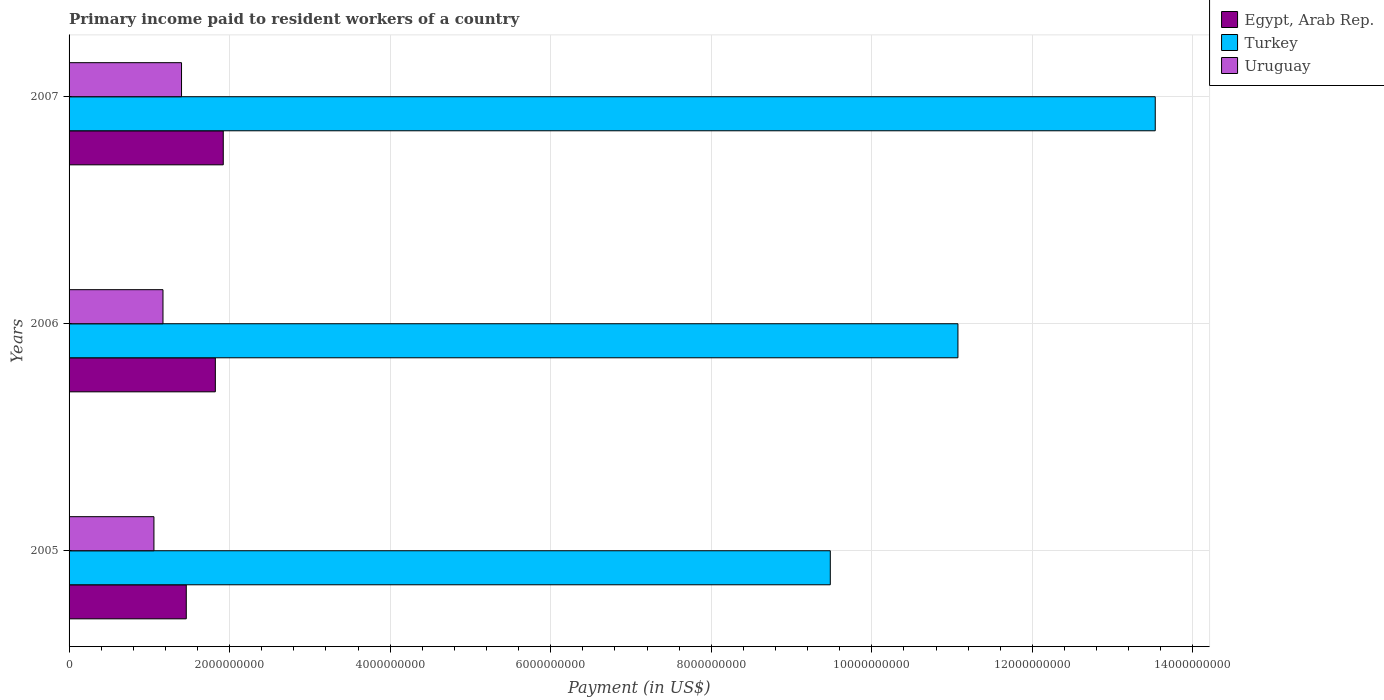How many different coloured bars are there?
Ensure brevity in your answer.  3. How many groups of bars are there?
Keep it short and to the point. 3. Are the number of bars per tick equal to the number of legend labels?
Your response must be concise. Yes. Are the number of bars on each tick of the Y-axis equal?
Ensure brevity in your answer.  Yes. How many bars are there on the 3rd tick from the top?
Your answer should be very brief. 3. In how many cases, is the number of bars for a given year not equal to the number of legend labels?
Keep it short and to the point. 0. What is the amount paid to workers in Uruguay in 2007?
Offer a terse response. 1.40e+09. Across all years, what is the maximum amount paid to workers in Egypt, Arab Rep.?
Give a very brief answer. 1.92e+09. Across all years, what is the minimum amount paid to workers in Turkey?
Your response must be concise. 9.48e+09. In which year was the amount paid to workers in Egypt, Arab Rep. minimum?
Your answer should be very brief. 2005. What is the total amount paid to workers in Uruguay in the graph?
Your answer should be compact. 3.63e+09. What is the difference between the amount paid to workers in Turkey in 2005 and that in 2006?
Your answer should be compact. -1.59e+09. What is the difference between the amount paid to workers in Egypt, Arab Rep. in 2006 and the amount paid to workers in Uruguay in 2005?
Offer a very short reply. 7.65e+08. What is the average amount paid to workers in Egypt, Arab Rep. per year?
Offer a terse response. 1.73e+09. In the year 2006, what is the difference between the amount paid to workers in Egypt, Arab Rep. and amount paid to workers in Turkey?
Give a very brief answer. -9.25e+09. What is the ratio of the amount paid to workers in Uruguay in 2006 to that in 2007?
Your response must be concise. 0.84. Is the difference between the amount paid to workers in Egypt, Arab Rep. in 2006 and 2007 greater than the difference between the amount paid to workers in Turkey in 2006 and 2007?
Provide a short and direct response. Yes. What is the difference between the highest and the second highest amount paid to workers in Uruguay?
Provide a short and direct response. 2.31e+08. What is the difference between the highest and the lowest amount paid to workers in Egypt, Arab Rep.?
Give a very brief answer. 4.61e+08. In how many years, is the amount paid to workers in Uruguay greater than the average amount paid to workers in Uruguay taken over all years?
Offer a very short reply. 1. Is the sum of the amount paid to workers in Uruguay in 2005 and 2006 greater than the maximum amount paid to workers in Egypt, Arab Rep. across all years?
Make the answer very short. Yes. What does the 2nd bar from the top in 2007 represents?
Keep it short and to the point. Turkey. What does the 1st bar from the bottom in 2007 represents?
Ensure brevity in your answer.  Egypt, Arab Rep. Is it the case that in every year, the sum of the amount paid to workers in Uruguay and amount paid to workers in Egypt, Arab Rep. is greater than the amount paid to workers in Turkey?
Keep it short and to the point. No. How many bars are there?
Your response must be concise. 9. Are all the bars in the graph horizontal?
Your answer should be compact. Yes. How many years are there in the graph?
Provide a short and direct response. 3. What is the difference between two consecutive major ticks on the X-axis?
Provide a succinct answer. 2.00e+09. Does the graph contain any zero values?
Your answer should be very brief. No. Where does the legend appear in the graph?
Offer a terse response. Top right. How are the legend labels stacked?
Provide a succinct answer. Vertical. What is the title of the graph?
Provide a short and direct response. Primary income paid to resident workers of a country. Does "Papua New Guinea" appear as one of the legend labels in the graph?
Offer a very short reply. No. What is the label or title of the X-axis?
Provide a succinct answer. Payment (in US$). What is the label or title of the Y-axis?
Ensure brevity in your answer.  Years. What is the Payment (in US$) of Egypt, Arab Rep. in 2005?
Provide a succinct answer. 1.46e+09. What is the Payment (in US$) of Turkey in 2005?
Ensure brevity in your answer.  9.48e+09. What is the Payment (in US$) of Uruguay in 2005?
Offer a terse response. 1.06e+09. What is the Payment (in US$) in Egypt, Arab Rep. in 2006?
Offer a very short reply. 1.82e+09. What is the Payment (in US$) of Turkey in 2006?
Ensure brevity in your answer.  1.11e+1. What is the Payment (in US$) of Uruguay in 2006?
Keep it short and to the point. 1.17e+09. What is the Payment (in US$) of Egypt, Arab Rep. in 2007?
Make the answer very short. 1.92e+09. What is the Payment (in US$) of Turkey in 2007?
Offer a terse response. 1.35e+1. What is the Payment (in US$) in Uruguay in 2007?
Offer a terse response. 1.40e+09. Across all years, what is the maximum Payment (in US$) in Egypt, Arab Rep.?
Ensure brevity in your answer.  1.92e+09. Across all years, what is the maximum Payment (in US$) of Turkey?
Your answer should be compact. 1.35e+1. Across all years, what is the maximum Payment (in US$) of Uruguay?
Provide a short and direct response. 1.40e+09. Across all years, what is the minimum Payment (in US$) in Egypt, Arab Rep.?
Provide a short and direct response. 1.46e+09. Across all years, what is the minimum Payment (in US$) in Turkey?
Keep it short and to the point. 9.48e+09. Across all years, what is the minimum Payment (in US$) of Uruguay?
Keep it short and to the point. 1.06e+09. What is the total Payment (in US$) of Egypt, Arab Rep. in the graph?
Your response must be concise. 5.20e+09. What is the total Payment (in US$) of Turkey in the graph?
Provide a short and direct response. 3.41e+1. What is the total Payment (in US$) of Uruguay in the graph?
Keep it short and to the point. 3.63e+09. What is the difference between the Payment (in US$) in Egypt, Arab Rep. in 2005 and that in 2006?
Provide a short and direct response. -3.62e+08. What is the difference between the Payment (in US$) of Turkey in 2005 and that in 2006?
Give a very brief answer. -1.59e+09. What is the difference between the Payment (in US$) of Uruguay in 2005 and that in 2006?
Your answer should be compact. -1.13e+08. What is the difference between the Payment (in US$) of Egypt, Arab Rep. in 2005 and that in 2007?
Make the answer very short. -4.61e+08. What is the difference between the Payment (in US$) of Turkey in 2005 and that in 2007?
Your response must be concise. -4.05e+09. What is the difference between the Payment (in US$) in Uruguay in 2005 and that in 2007?
Ensure brevity in your answer.  -3.44e+08. What is the difference between the Payment (in US$) in Egypt, Arab Rep. in 2006 and that in 2007?
Provide a succinct answer. -9.87e+07. What is the difference between the Payment (in US$) in Turkey in 2006 and that in 2007?
Your answer should be very brief. -2.46e+09. What is the difference between the Payment (in US$) of Uruguay in 2006 and that in 2007?
Provide a succinct answer. -2.31e+08. What is the difference between the Payment (in US$) in Egypt, Arab Rep. in 2005 and the Payment (in US$) in Turkey in 2006?
Your answer should be very brief. -9.61e+09. What is the difference between the Payment (in US$) of Egypt, Arab Rep. in 2005 and the Payment (in US$) of Uruguay in 2006?
Provide a succinct answer. 2.90e+08. What is the difference between the Payment (in US$) of Turkey in 2005 and the Payment (in US$) of Uruguay in 2006?
Offer a terse response. 8.31e+09. What is the difference between the Payment (in US$) of Egypt, Arab Rep. in 2005 and the Payment (in US$) of Turkey in 2007?
Provide a short and direct response. -1.21e+1. What is the difference between the Payment (in US$) of Egypt, Arab Rep. in 2005 and the Payment (in US$) of Uruguay in 2007?
Offer a very short reply. 5.93e+07. What is the difference between the Payment (in US$) in Turkey in 2005 and the Payment (in US$) in Uruguay in 2007?
Ensure brevity in your answer.  8.08e+09. What is the difference between the Payment (in US$) in Egypt, Arab Rep. in 2006 and the Payment (in US$) in Turkey in 2007?
Your answer should be very brief. -1.17e+1. What is the difference between the Payment (in US$) of Egypt, Arab Rep. in 2006 and the Payment (in US$) of Uruguay in 2007?
Your answer should be very brief. 4.21e+08. What is the difference between the Payment (in US$) in Turkey in 2006 and the Payment (in US$) in Uruguay in 2007?
Give a very brief answer. 9.67e+09. What is the average Payment (in US$) of Egypt, Arab Rep. per year?
Provide a succinct answer. 1.73e+09. What is the average Payment (in US$) in Turkey per year?
Offer a terse response. 1.14e+1. What is the average Payment (in US$) of Uruguay per year?
Your answer should be very brief. 1.21e+09. In the year 2005, what is the difference between the Payment (in US$) in Egypt, Arab Rep. and Payment (in US$) in Turkey?
Offer a terse response. -8.02e+09. In the year 2005, what is the difference between the Payment (in US$) in Egypt, Arab Rep. and Payment (in US$) in Uruguay?
Keep it short and to the point. 4.03e+08. In the year 2005, what is the difference between the Payment (in US$) in Turkey and Payment (in US$) in Uruguay?
Ensure brevity in your answer.  8.43e+09. In the year 2006, what is the difference between the Payment (in US$) in Egypt, Arab Rep. and Payment (in US$) in Turkey?
Make the answer very short. -9.25e+09. In the year 2006, what is the difference between the Payment (in US$) of Egypt, Arab Rep. and Payment (in US$) of Uruguay?
Your answer should be compact. 6.52e+08. In the year 2006, what is the difference between the Payment (in US$) of Turkey and Payment (in US$) of Uruguay?
Your answer should be compact. 9.90e+09. In the year 2007, what is the difference between the Payment (in US$) of Egypt, Arab Rep. and Payment (in US$) of Turkey?
Provide a succinct answer. -1.16e+1. In the year 2007, what is the difference between the Payment (in US$) in Egypt, Arab Rep. and Payment (in US$) in Uruguay?
Offer a terse response. 5.20e+08. In the year 2007, what is the difference between the Payment (in US$) in Turkey and Payment (in US$) in Uruguay?
Provide a succinct answer. 1.21e+1. What is the ratio of the Payment (in US$) of Egypt, Arab Rep. in 2005 to that in 2006?
Offer a very short reply. 0.8. What is the ratio of the Payment (in US$) in Turkey in 2005 to that in 2006?
Your response must be concise. 0.86. What is the ratio of the Payment (in US$) of Uruguay in 2005 to that in 2006?
Ensure brevity in your answer.  0.9. What is the ratio of the Payment (in US$) in Egypt, Arab Rep. in 2005 to that in 2007?
Make the answer very short. 0.76. What is the ratio of the Payment (in US$) in Turkey in 2005 to that in 2007?
Your answer should be very brief. 0.7. What is the ratio of the Payment (in US$) in Uruguay in 2005 to that in 2007?
Keep it short and to the point. 0.75. What is the ratio of the Payment (in US$) in Egypt, Arab Rep. in 2006 to that in 2007?
Give a very brief answer. 0.95. What is the ratio of the Payment (in US$) of Turkey in 2006 to that in 2007?
Offer a terse response. 0.82. What is the ratio of the Payment (in US$) in Uruguay in 2006 to that in 2007?
Keep it short and to the point. 0.83. What is the difference between the highest and the second highest Payment (in US$) in Egypt, Arab Rep.?
Keep it short and to the point. 9.87e+07. What is the difference between the highest and the second highest Payment (in US$) in Turkey?
Keep it short and to the point. 2.46e+09. What is the difference between the highest and the second highest Payment (in US$) of Uruguay?
Keep it short and to the point. 2.31e+08. What is the difference between the highest and the lowest Payment (in US$) of Egypt, Arab Rep.?
Provide a succinct answer. 4.61e+08. What is the difference between the highest and the lowest Payment (in US$) in Turkey?
Give a very brief answer. 4.05e+09. What is the difference between the highest and the lowest Payment (in US$) of Uruguay?
Your answer should be very brief. 3.44e+08. 